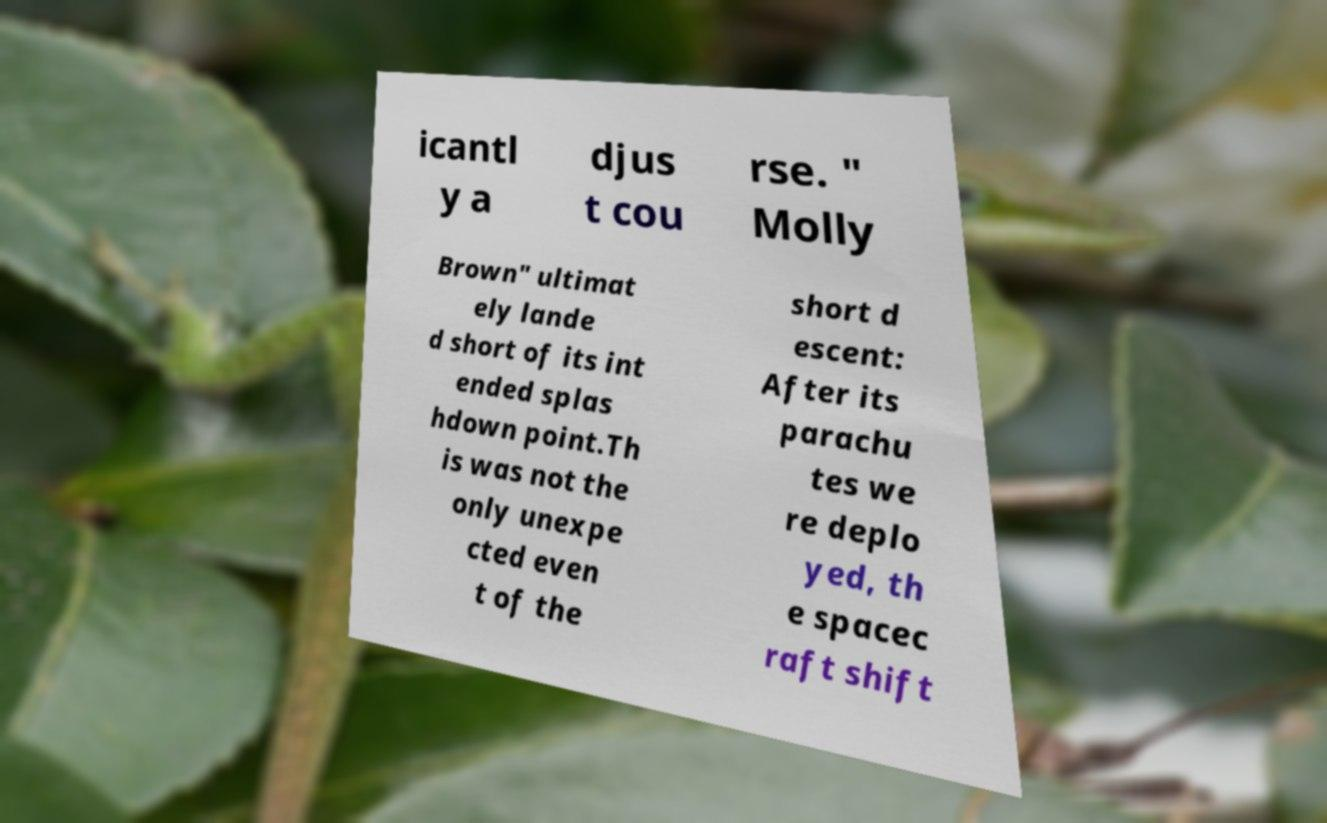For documentation purposes, I need the text within this image transcribed. Could you provide that? icantl y a djus t cou rse. " Molly Brown" ultimat ely lande d short of its int ended splas hdown point.Th is was not the only unexpe cted even t of the short d escent: After its parachu tes we re deplo yed, th e spacec raft shift 